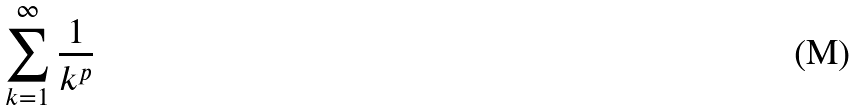Convert formula to latex. <formula><loc_0><loc_0><loc_500><loc_500>\sum _ { k = 1 } ^ { \infty } \frac { 1 } { k ^ { p } }</formula> 